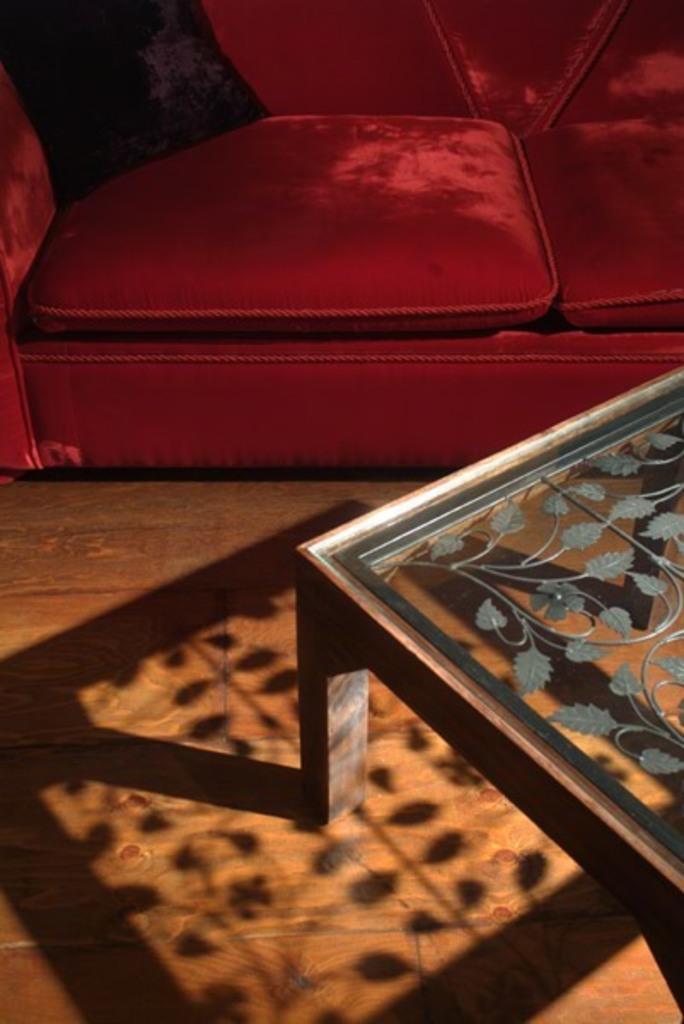In one or two sentences, can you explain what this image depicts? This picture is mainly highlighted with a red colour sofa and a glass table on the floor. 